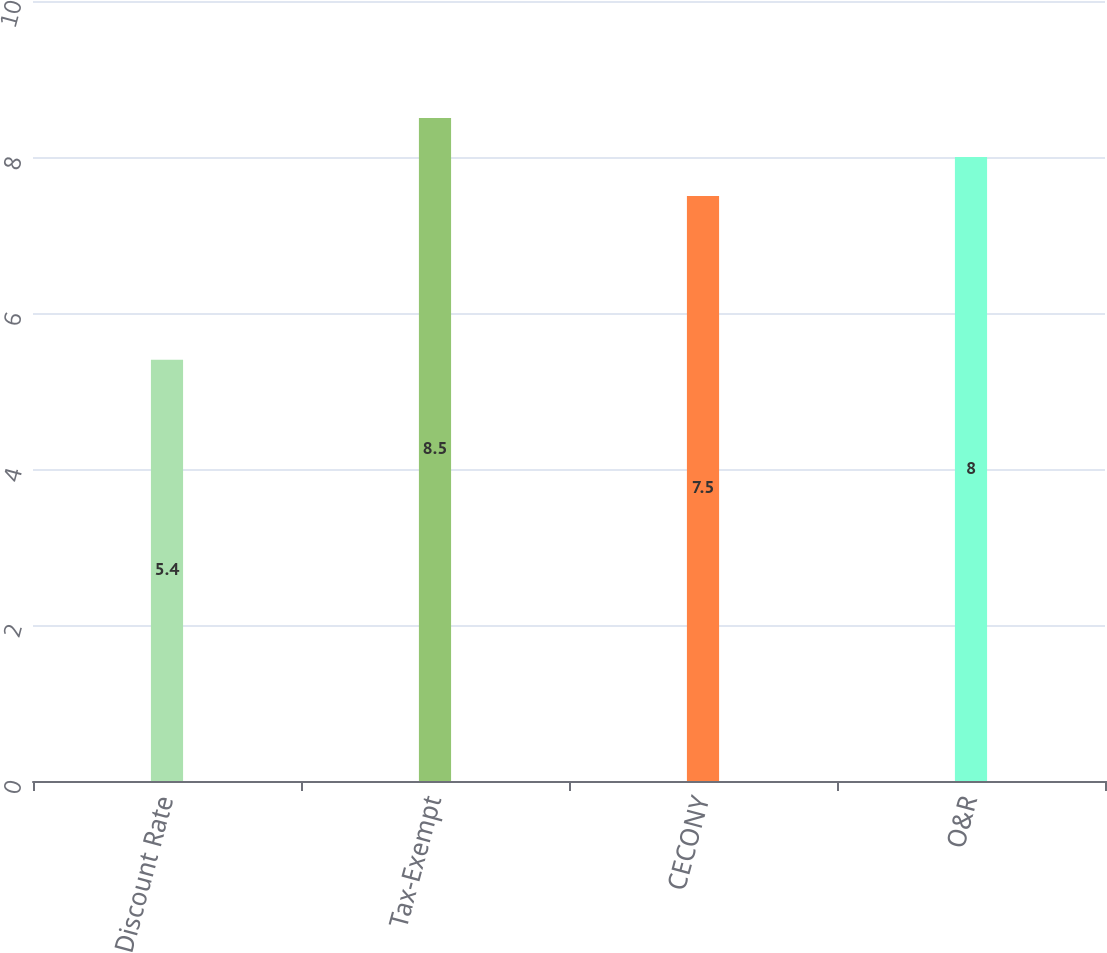Convert chart to OTSL. <chart><loc_0><loc_0><loc_500><loc_500><bar_chart><fcel>Discount Rate<fcel>Tax-Exempt<fcel>CECONY<fcel>O&R<nl><fcel>5.4<fcel>8.5<fcel>7.5<fcel>8<nl></chart> 